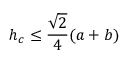<formula> <loc_0><loc_0><loc_500><loc_500>h _ { c } \leq { \frac { \sqrt { 2 } } { 4 } } ( a + b )</formula> 